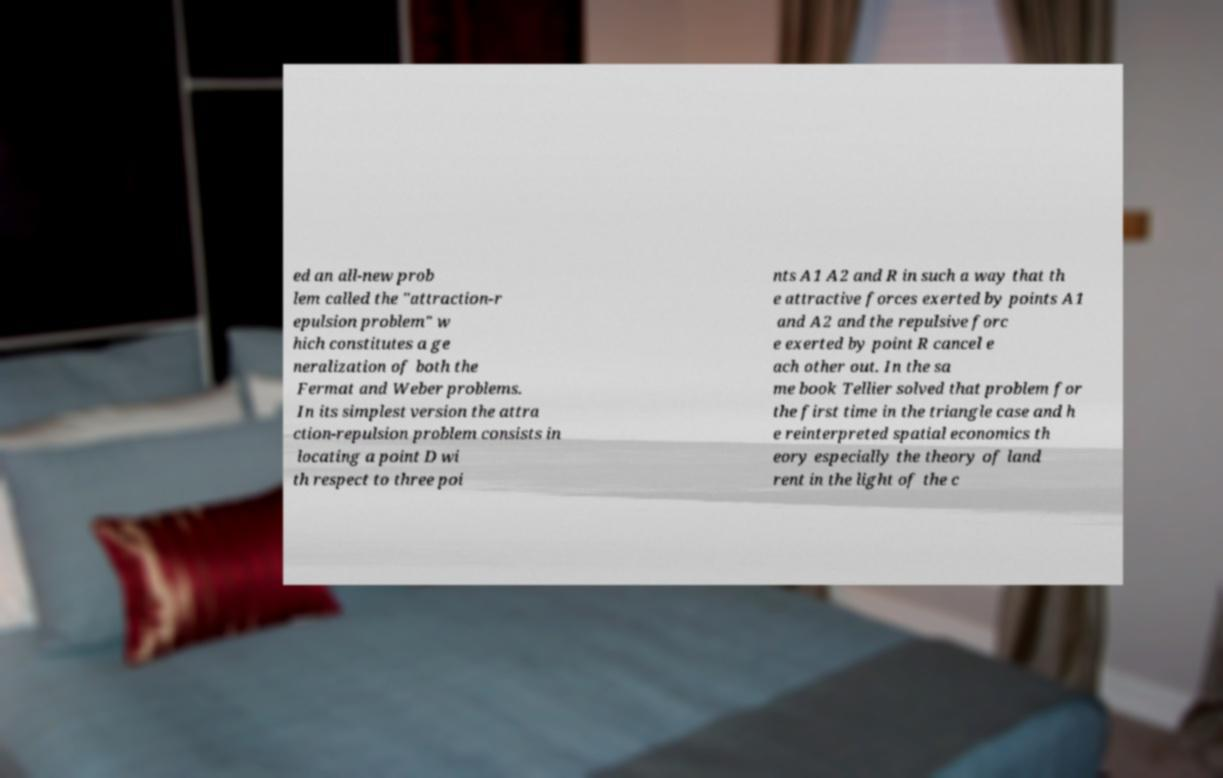Please read and relay the text visible in this image. What does it say? ed an all-new prob lem called the "attraction-r epulsion problem" w hich constitutes a ge neralization of both the Fermat and Weber problems. In its simplest version the attra ction-repulsion problem consists in locating a point D wi th respect to three poi nts A1 A2 and R in such a way that th e attractive forces exerted by points A1 and A2 and the repulsive forc e exerted by point R cancel e ach other out. In the sa me book Tellier solved that problem for the first time in the triangle case and h e reinterpreted spatial economics th eory especially the theory of land rent in the light of the c 